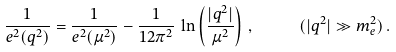Convert formula to latex. <formula><loc_0><loc_0><loc_500><loc_500>\frac { 1 } { e ^ { 2 } ( q ^ { 2 } ) } = \frac { 1 } { e ^ { 2 } ( \mu ^ { 2 } ) } - \frac { 1 } { 1 2 \pi ^ { 2 } } \, \ln \left ( \frac { | q ^ { 2 } | } { \mu ^ { 2 } } \right ) \, , \quad \ \ ( | q ^ { 2 } | \gg m _ { e } ^ { 2 } ) \, .</formula> 